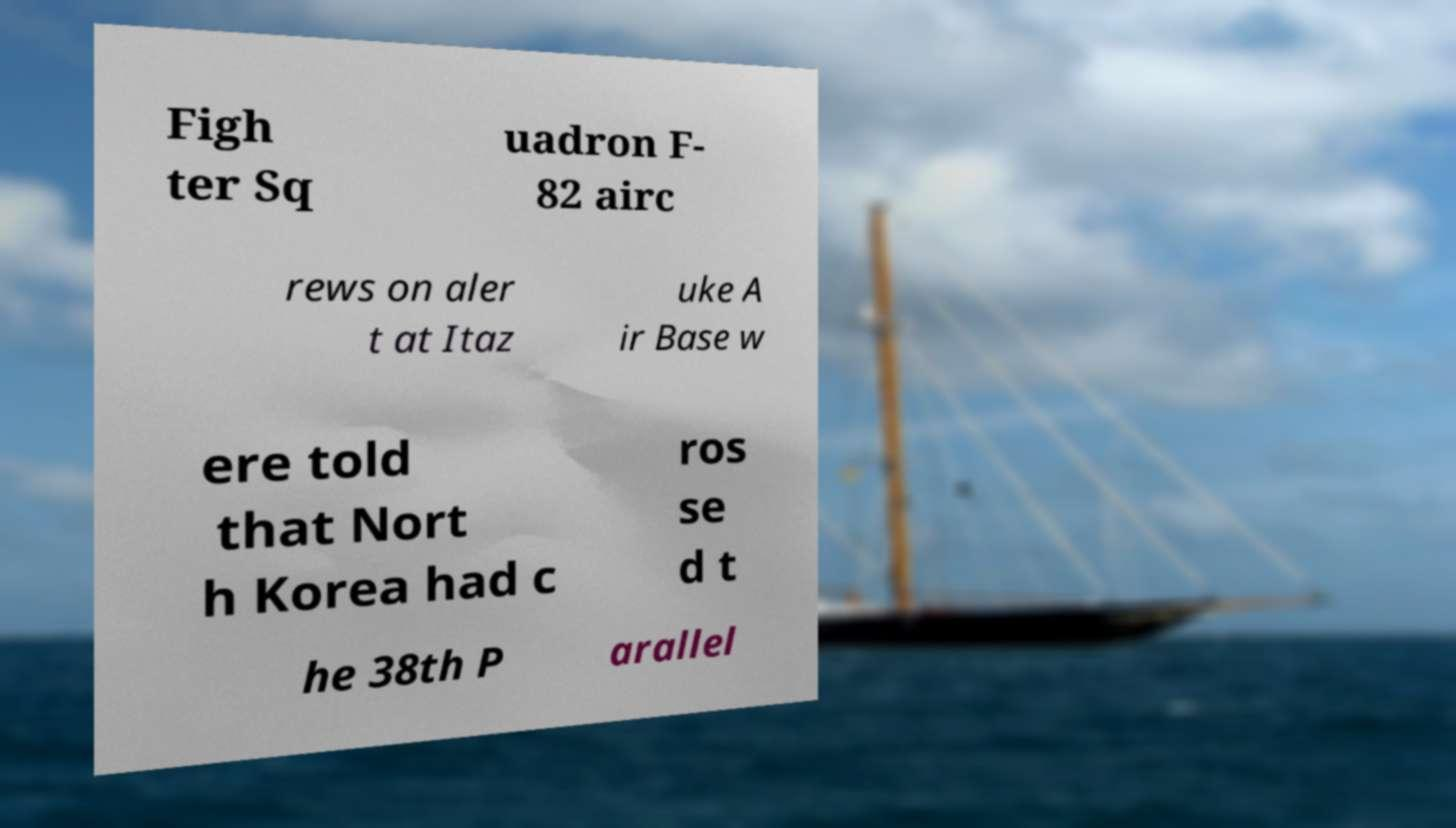Please read and relay the text visible in this image. What does it say? Figh ter Sq uadron F- 82 airc rews on aler t at Itaz uke A ir Base w ere told that Nort h Korea had c ros se d t he 38th P arallel 